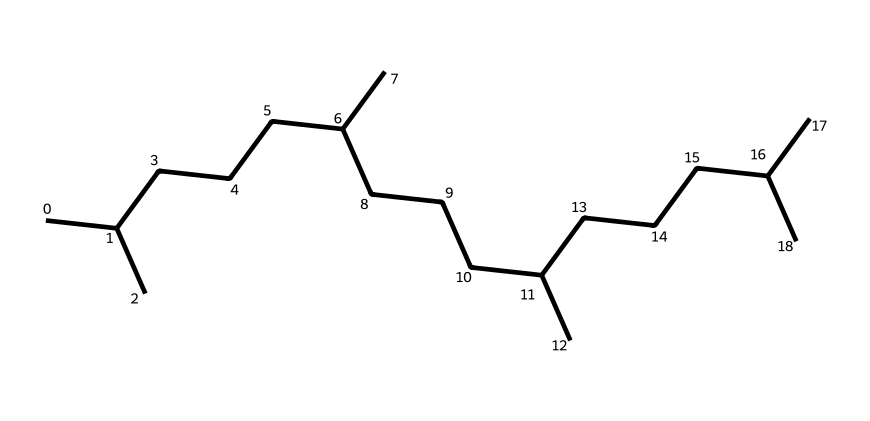What is the total number of carbon atoms present in this chemical structure? By analyzing the SMILES representation, we count the total number of "C" symbols, which indicates the number of carbon atoms. There are 30 carbon atoms in total.
Answer: 30 What type of hydrocarbon does this chemical structure represent? The structure consists solely of carbon and hydrogen atoms, with no functional groups or polar parts present. This indicates that it is a saturated hydrocarbon, specifically an alkane.
Answer: alkane How many branches are present in the chemical structure? In the given SMILES representation, we can identify branches by looking at the carbon atoms paired with additional carbon chains. There are five branched structures in this molecule.
Answer: 5 What is the degree of saturation of this alkane? The degree of saturation can be calculated using the formula for alkanes, CnH(2n+2). With 30 carbon atoms (n=30), the theoretical hydrogen count should be 62. Since we're looking at a saturated hydrocarbon, it follows this formula.
Answer: 62 Does this substance likely have ionic properties? Since non-electrolytes do not dissociate into ions in solution and this chemical structure is an alkane with no polar functional groups, it will not have ionic properties.
Answer: no 